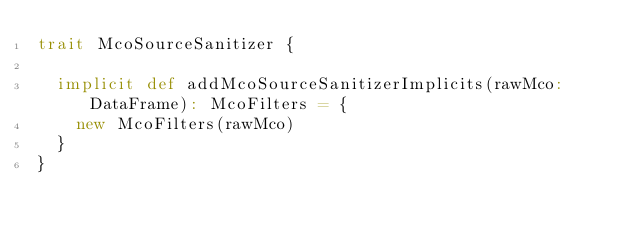Convert code to text. <code><loc_0><loc_0><loc_500><loc_500><_Scala_>trait McoSourceSanitizer {

  implicit def addMcoSourceSanitizerImplicits(rawMco: DataFrame): McoFilters = {
    new McoFilters(rawMco)
  }
}
</code> 